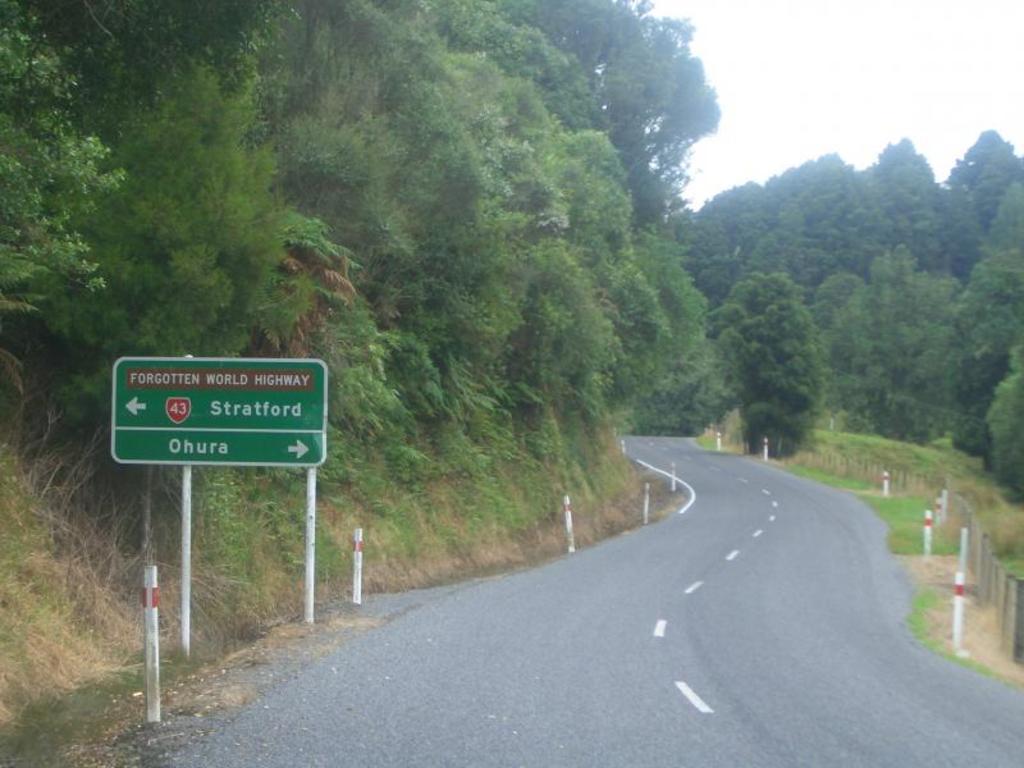Which way to ohura?
Keep it short and to the point. Right. 